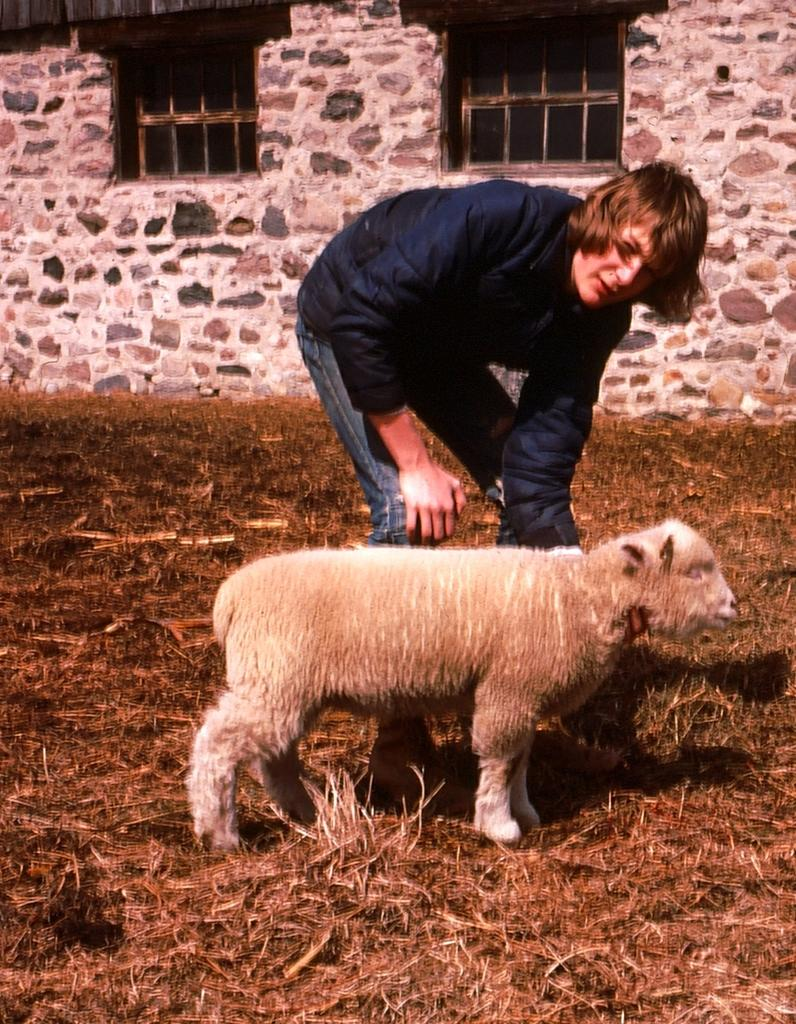What is the person in the image standing on? The person is standing on the surface of dry grass. What animal is in front of the person? There is a sheep in front of the person. What can be seen in the background of the image? There is a building in the background of the image. How many giants are visible in the image? There are no giants present in the image. What type of metal is used to construct the sheep in the image? The image features a real sheep, not a metal one, so there is no metal used in its construction. 